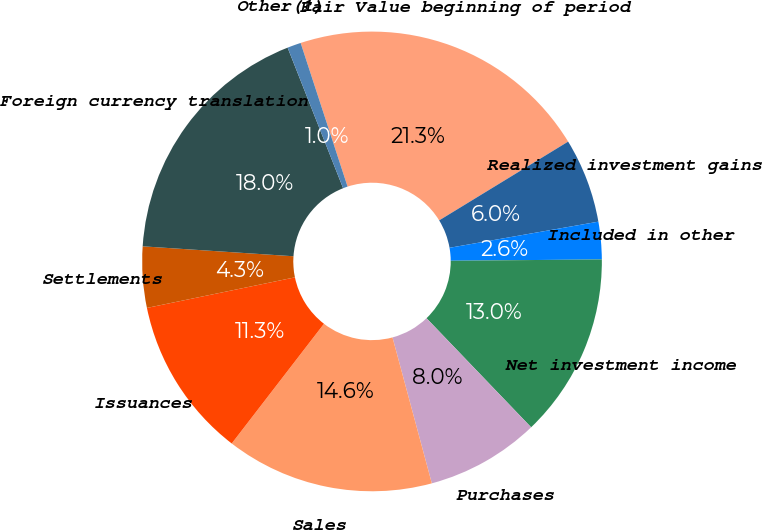<chart> <loc_0><loc_0><loc_500><loc_500><pie_chart><fcel>Fair Value beginning of period<fcel>Realized investment gains<fcel>Included in other<fcel>Net investment income<fcel>Purchases<fcel>Sales<fcel>Issuances<fcel>Settlements<fcel>Foreign currency translation<fcel>Other(1)<nl><fcel>21.3%<fcel>5.96%<fcel>2.63%<fcel>12.97%<fcel>7.98%<fcel>14.64%<fcel>11.31%<fcel>4.29%<fcel>17.97%<fcel>0.96%<nl></chart> 